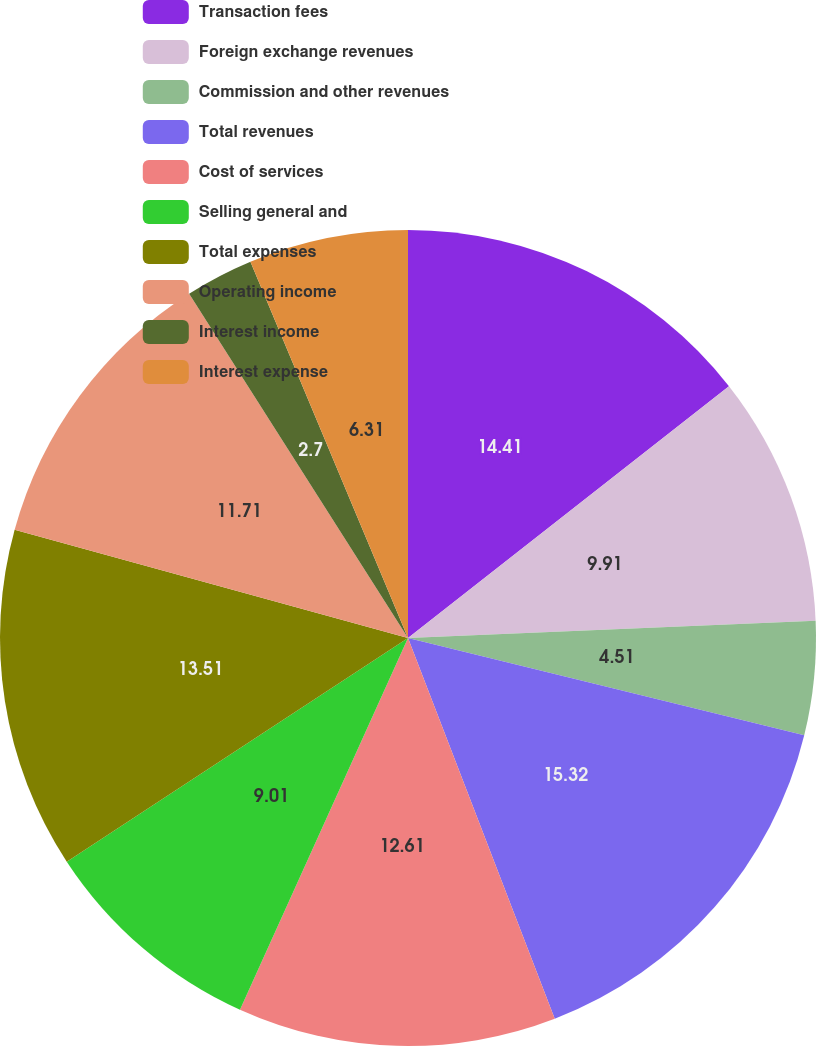Convert chart to OTSL. <chart><loc_0><loc_0><loc_500><loc_500><pie_chart><fcel>Transaction fees<fcel>Foreign exchange revenues<fcel>Commission and other revenues<fcel>Total revenues<fcel>Cost of services<fcel>Selling general and<fcel>Total expenses<fcel>Operating income<fcel>Interest income<fcel>Interest expense<nl><fcel>14.41%<fcel>9.91%<fcel>4.51%<fcel>15.31%<fcel>12.61%<fcel>9.01%<fcel>13.51%<fcel>11.71%<fcel>2.7%<fcel>6.31%<nl></chart> 